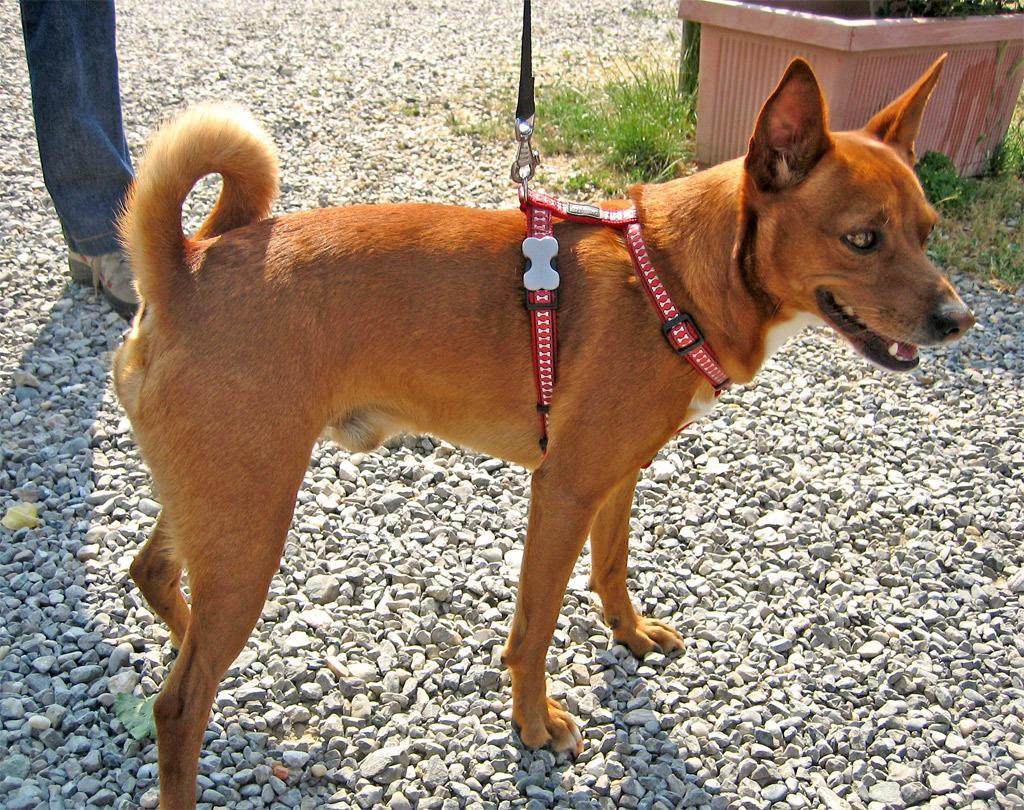In one or two sentences, can you explain what this image depicts? In this image a dog is standing. A chain is attached to its body. On the top left a leg is visible. On the top right there is a pot. There are some pebbles on the ground. 